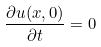<formula> <loc_0><loc_0><loc_500><loc_500>\frac { \partial u ( x , 0 ) } { \partial t } = 0</formula> 